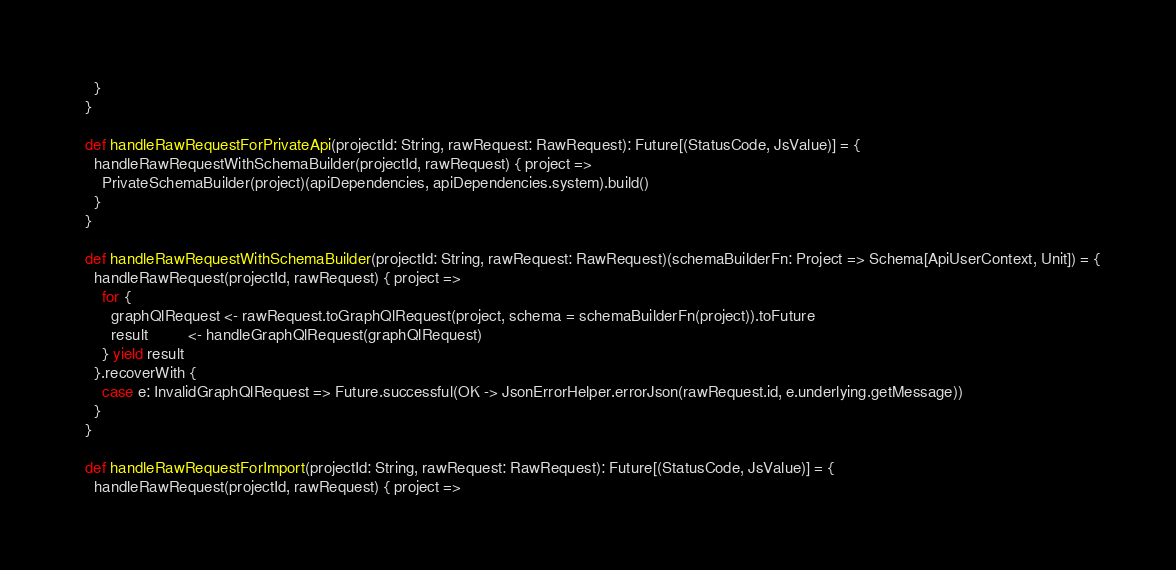Convert code to text. <code><loc_0><loc_0><loc_500><loc_500><_Scala_>    }
  }

  def handleRawRequestForPrivateApi(projectId: String, rawRequest: RawRequest): Future[(StatusCode, JsValue)] = {
    handleRawRequestWithSchemaBuilder(projectId, rawRequest) { project =>
      PrivateSchemaBuilder(project)(apiDependencies, apiDependencies.system).build()
    }
  }

  def handleRawRequestWithSchemaBuilder(projectId: String, rawRequest: RawRequest)(schemaBuilderFn: Project => Schema[ApiUserContext, Unit]) = {
    handleRawRequest(projectId, rawRequest) { project =>
      for {
        graphQlRequest <- rawRequest.toGraphQlRequest(project, schema = schemaBuilderFn(project)).toFuture
        result         <- handleGraphQlRequest(graphQlRequest)
      } yield result
    }.recoverWith {
      case e: InvalidGraphQlRequest => Future.successful(OK -> JsonErrorHelper.errorJson(rawRequest.id, e.underlying.getMessage))
    }
  }

  def handleRawRequestForImport(projectId: String, rawRequest: RawRequest): Future[(StatusCode, JsValue)] = {
    handleRawRequest(projectId, rawRequest) { project =></code> 